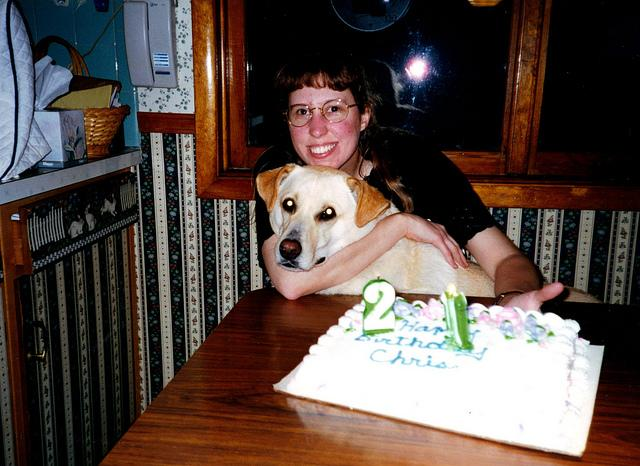Where is the dog sitting?

Choices:
A) bench
B) crate
C) window
D) girls lap girls lap 